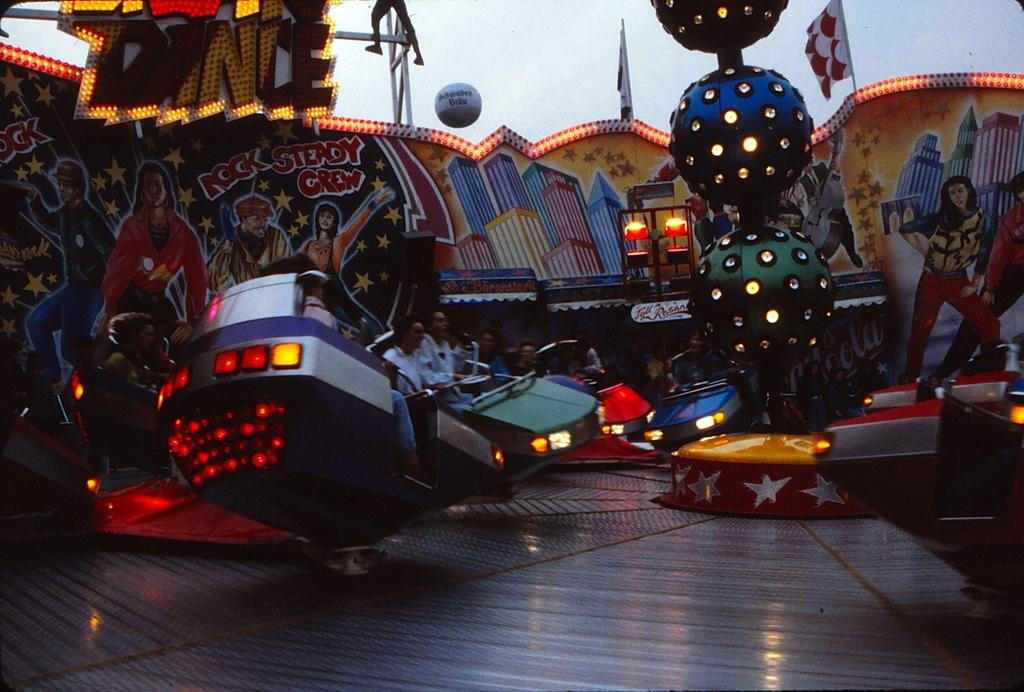What are the people in the image doing? The people in the image are on rides. What else can be seen in the image besides the people on rides? There are posters and lights visible in the image. What type of gold can be seen in the sack carried by the person in the image? There is no person carrying a sack in the image, nor is there any gold present. 